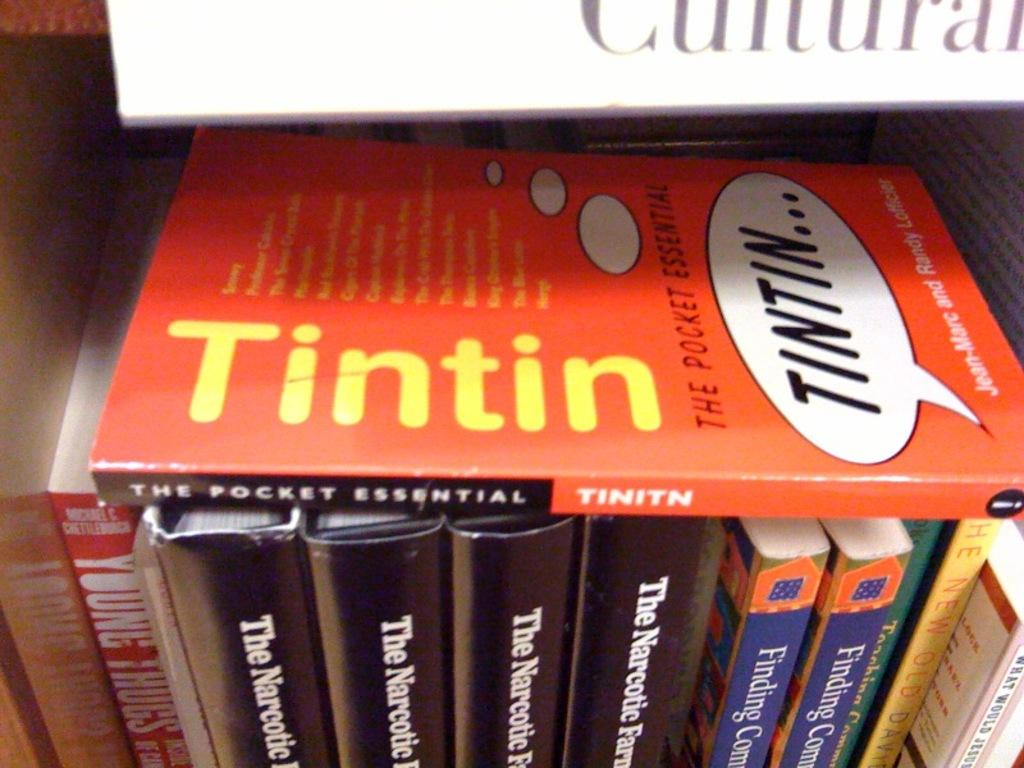<image>
Relay a brief, clear account of the picture shown. The book, "Tintin" is on top of several other books. 